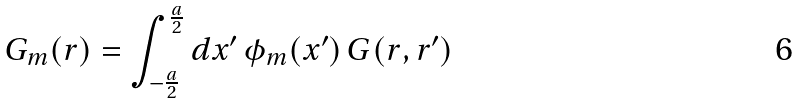Convert formula to latex. <formula><loc_0><loc_0><loc_500><loc_500>G _ { m } ( { r } ) = \int _ { - \frac { a } { 2 } } ^ { \frac { a } { 2 } } d x ^ { \prime } \, \phi _ { m } ( x ^ { \prime } ) \, G ( r , r ^ { \prime } )</formula> 